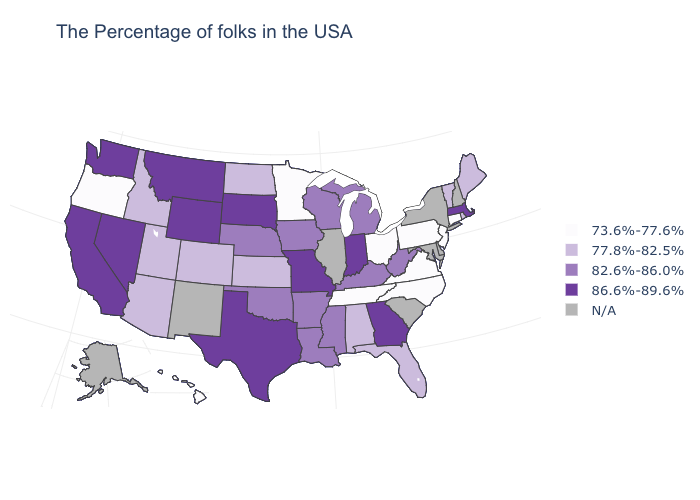What is the highest value in the USA?
Answer briefly. 86.6%-89.6%. What is the value of Rhode Island?
Give a very brief answer. 77.8%-82.5%. Does the map have missing data?
Write a very short answer. Yes. What is the lowest value in the South?
Write a very short answer. 73.6%-77.6%. Does Minnesota have the highest value in the USA?
Quick response, please. No. What is the value of Wisconsin?
Keep it brief. 82.6%-86.0%. Among the states that border Florida , does Georgia have the lowest value?
Answer briefly. No. Name the states that have a value in the range 86.6%-89.6%?
Write a very short answer. Massachusetts, Georgia, Indiana, Missouri, Texas, South Dakota, Wyoming, Montana, Nevada, California, Washington. What is the value of Kansas?
Write a very short answer. 77.8%-82.5%. What is the value of Tennessee?
Answer briefly. 73.6%-77.6%. What is the lowest value in states that border Arkansas?
Give a very brief answer. 73.6%-77.6%. Among the states that border North Dakota , does Minnesota have the highest value?
Give a very brief answer. No. What is the value of Florida?
Give a very brief answer. 77.8%-82.5%. Which states hav the highest value in the South?
Quick response, please. Georgia, Texas. Does the first symbol in the legend represent the smallest category?
Be succinct. Yes. 